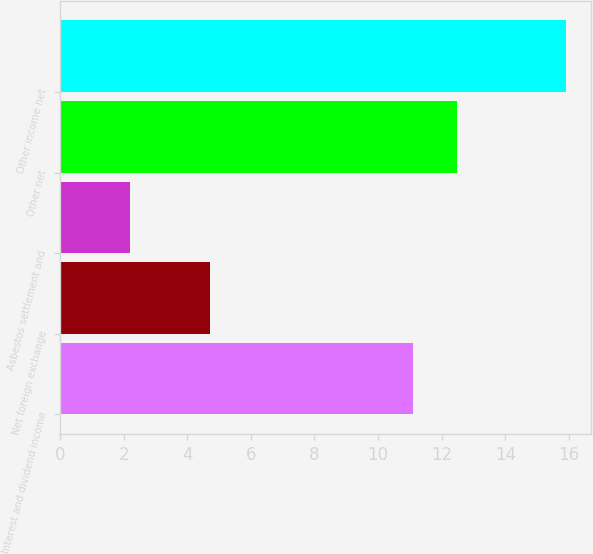Convert chart. <chart><loc_0><loc_0><loc_500><loc_500><bar_chart><fcel>Interest and dividend income<fcel>Net foreign exchange<fcel>Asbestos settlement and<fcel>Other net<fcel>Other income net<nl><fcel>11.1<fcel>4.7<fcel>2.2<fcel>12.47<fcel>15.9<nl></chart> 